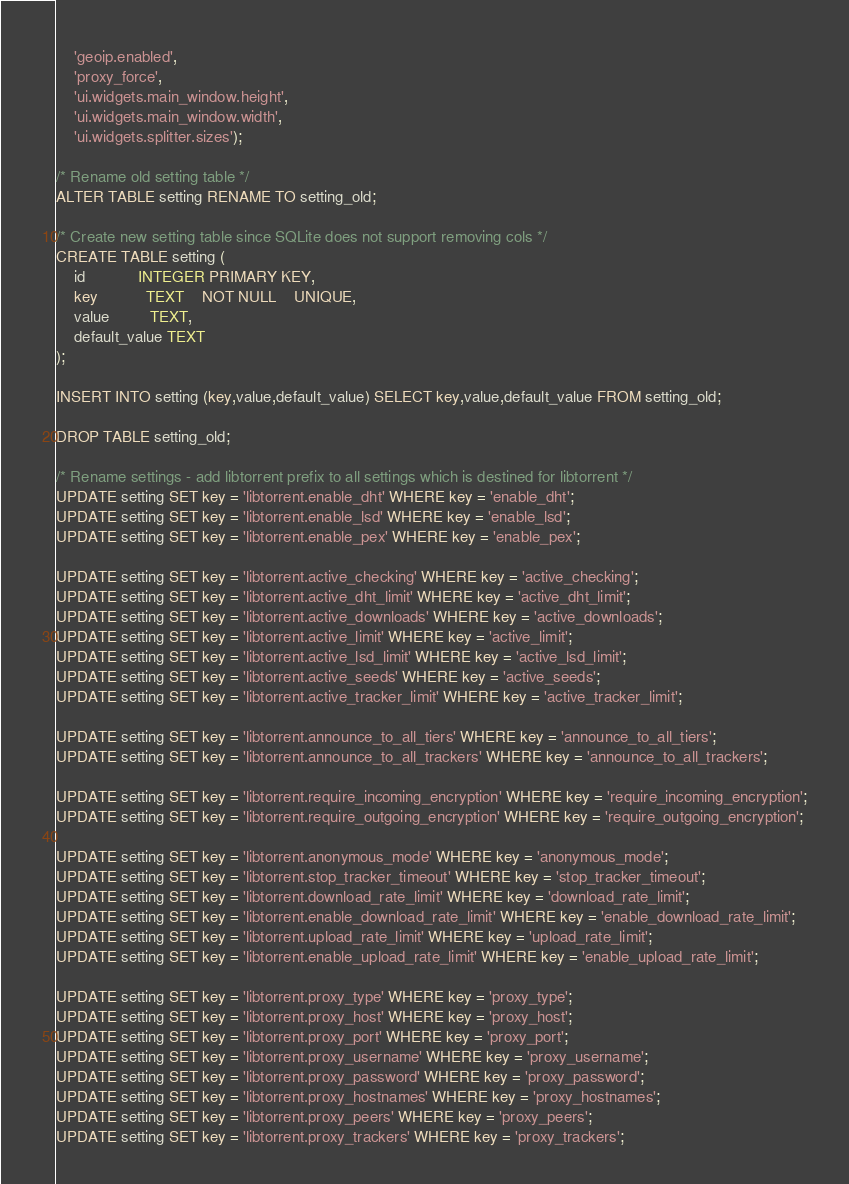<code> <loc_0><loc_0><loc_500><loc_500><_SQL_>    'geoip.enabled',
    'proxy_force',
    'ui.widgets.main_window.height',
    'ui.widgets.main_window.width',
    'ui.widgets.splitter.sizes');

/* Rename old setting table */
ALTER TABLE setting RENAME TO setting_old;

/* Create new setting table since SQLite does not support removing cols */
CREATE TABLE setting (
    id            INTEGER PRIMARY KEY,
    key           TEXT    NOT NULL    UNIQUE,
    value         TEXT,
    default_value TEXT
);

INSERT INTO setting (key,value,default_value) SELECT key,value,default_value FROM setting_old;

DROP TABLE setting_old;

/* Rename settings - add libtorrent prefix to all settings which is destined for libtorrent */
UPDATE setting SET key = 'libtorrent.enable_dht' WHERE key = 'enable_dht';
UPDATE setting SET key = 'libtorrent.enable_lsd' WHERE key = 'enable_lsd';
UPDATE setting SET key = 'libtorrent.enable_pex' WHERE key = 'enable_pex';

UPDATE setting SET key = 'libtorrent.active_checking' WHERE key = 'active_checking';
UPDATE setting SET key = 'libtorrent.active_dht_limit' WHERE key = 'active_dht_limit';
UPDATE setting SET key = 'libtorrent.active_downloads' WHERE key = 'active_downloads';
UPDATE setting SET key = 'libtorrent.active_limit' WHERE key = 'active_limit';
UPDATE setting SET key = 'libtorrent.active_lsd_limit' WHERE key = 'active_lsd_limit';
UPDATE setting SET key = 'libtorrent.active_seeds' WHERE key = 'active_seeds';
UPDATE setting SET key = 'libtorrent.active_tracker_limit' WHERE key = 'active_tracker_limit';

UPDATE setting SET key = 'libtorrent.announce_to_all_tiers' WHERE key = 'announce_to_all_tiers';
UPDATE setting SET key = 'libtorrent.announce_to_all_trackers' WHERE key = 'announce_to_all_trackers';

UPDATE setting SET key = 'libtorrent.require_incoming_encryption' WHERE key = 'require_incoming_encryption';
UPDATE setting SET key = 'libtorrent.require_outgoing_encryption' WHERE key = 'require_outgoing_encryption';

UPDATE setting SET key = 'libtorrent.anonymous_mode' WHERE key = 'anonymous_mode';
UPDATE setting SET key = 'libtorrent.stop_tracker_timeout' WHERE key = 'stop_tracker_timeout';
UPDATE setting SET key = 'libtorrent.download_rate_limit' WHERE key = 'download_rate_limit';
UPDATE setting SET key = 'libtorrent.enable_download_rate_limit' WHERE key = 'enable_download_rate_limit';
UPDATE setting SET key = 'libtorrent.upload_rate_limit' WHERE key = 'upload_rate_limit';
UPDATE setting SET key = 'libtorrent.enable_upload_rate_limit' WHERE key = 'enable_upload_rate_limit';

UPDATE setting SET key = 'libtorrent.proxy_type' WHERE key = 'proxy_type';
UPDATE setting SET key = 'libtorrent.proxy_host' WHERE key = 'proxy_host';
UPDATE setting SET key = 'libtorrent.proxy_port' WHERE key = 'proxy_port';
UPDATE setting SET key = 'libtorrent.proxy_username' WHERE key = 'proxy_username';
UPDATE setting SET key = 'libtorrent.proxy_password' WHERE key = 'proxy_password';
UPDATE setting SET key = 'libtorrent.proxy_hostnames' WHERE key = 'proxy_hostnames';
UPDATE setting SET key = 'libtorrent.proxy_peers' WHERE key = 'proxy_peers';
UPDATE setting SET key = 'libtorrent.proxy_trackers' WHERE key = 'proxy_trackers';
</code> 